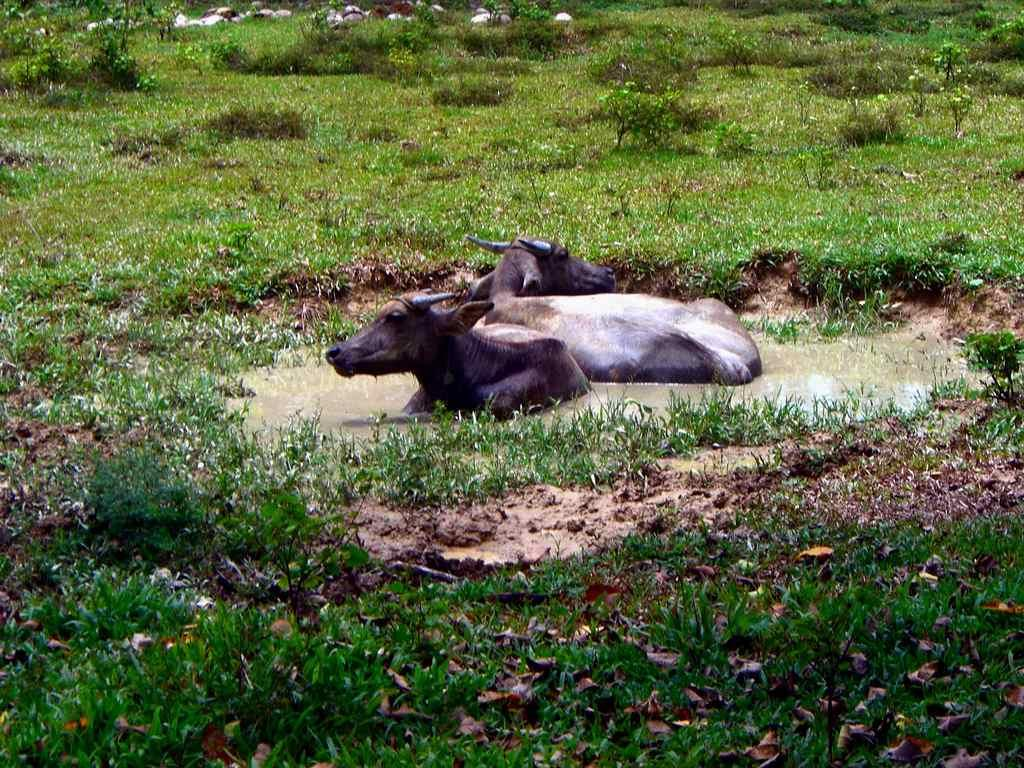What is happening in the water in the image? There are animals in the water in the image. What can be seen in the background of the image? There are plants and grass in the background of the image. Can you see a sail in the image? There is no sail present in the image. Is there a rifle visible in the image? There is no rifle present in the image. 